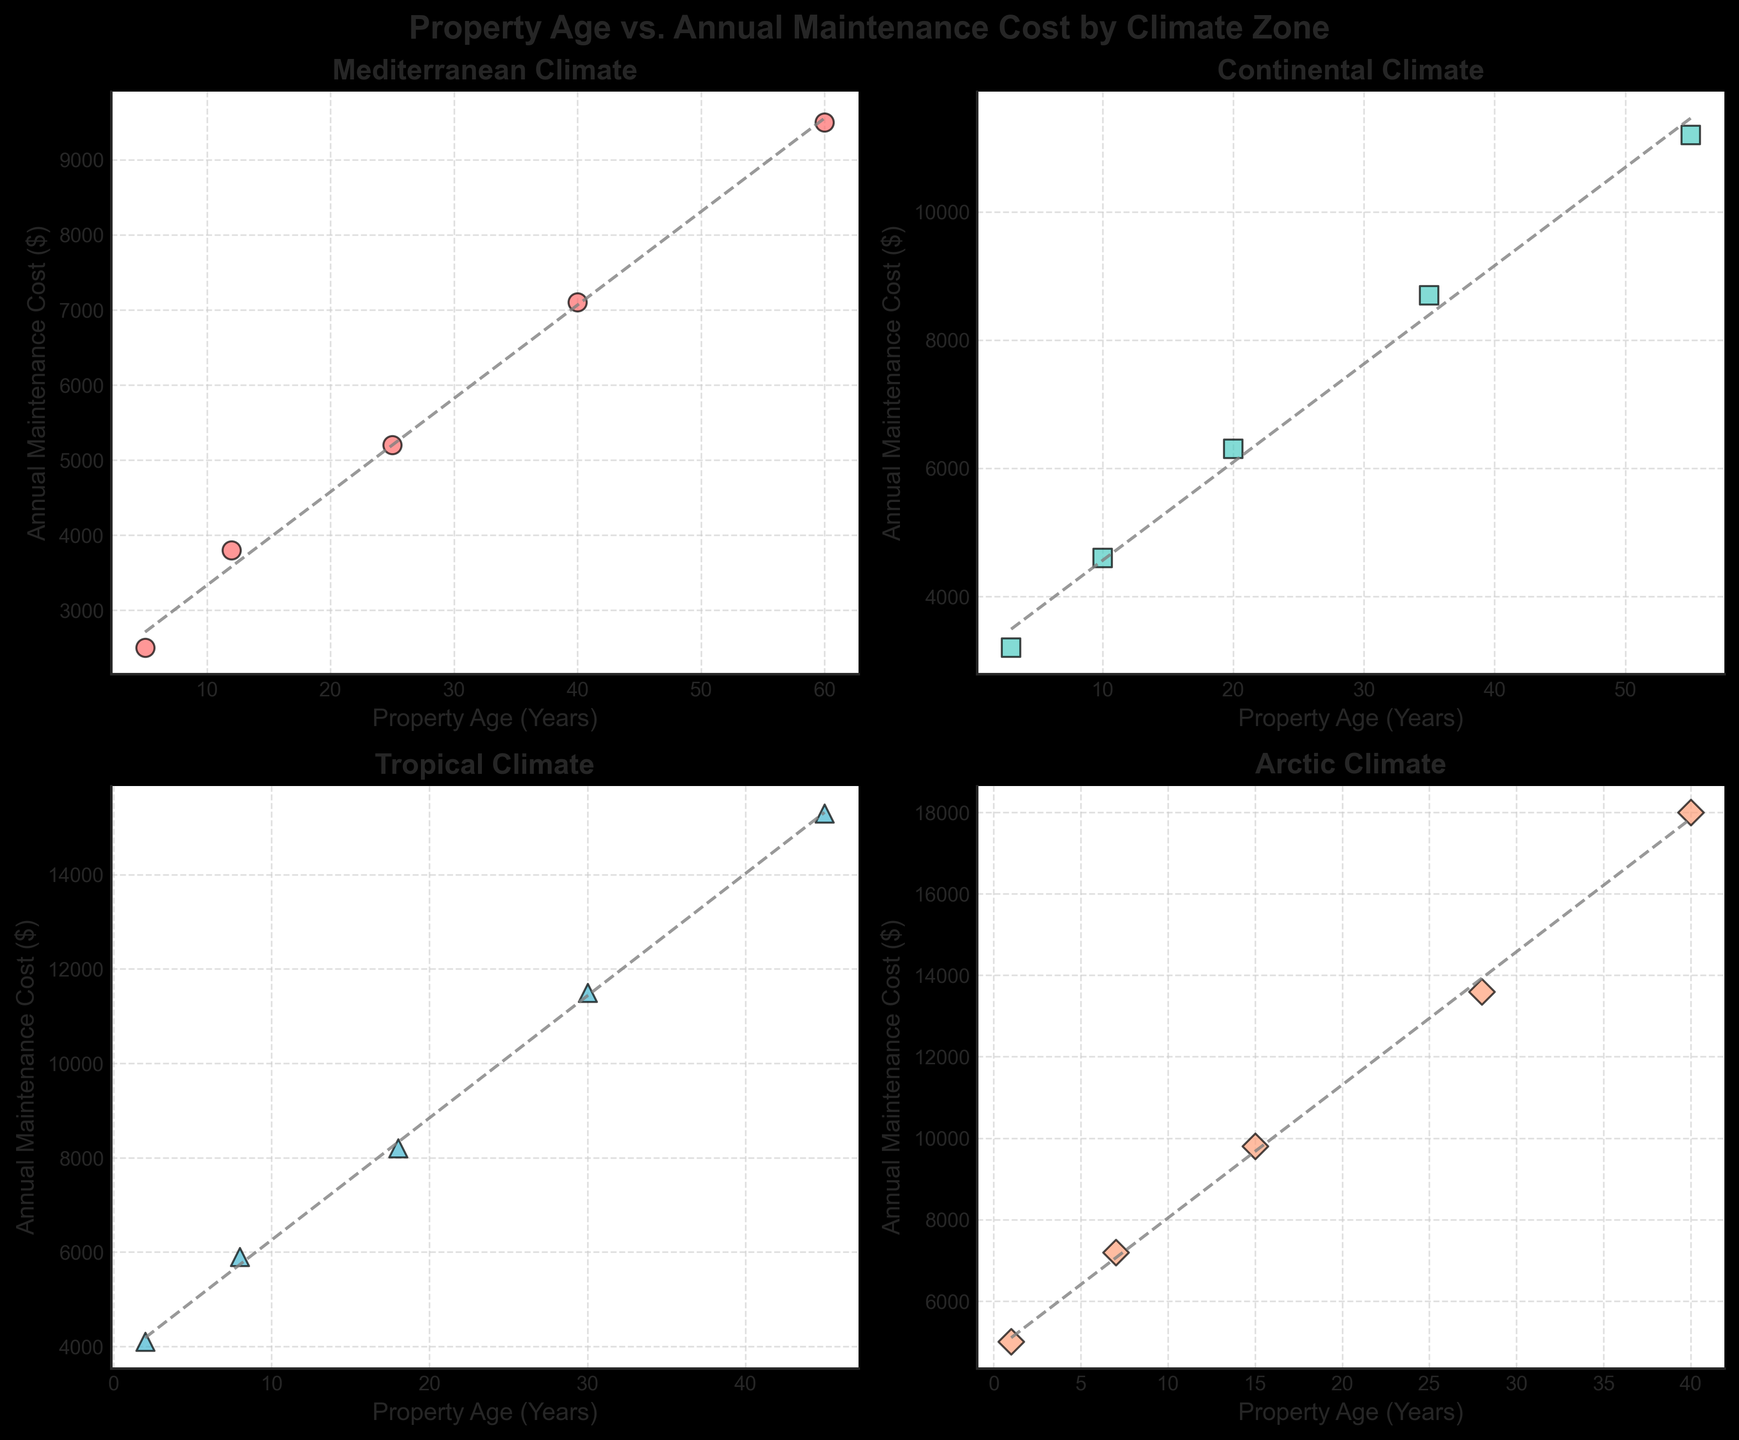What is the title of the figure? The title of the figure is located at the top, typically in bold font. It is a textual component that provides a summary of what the figure is about.
Answer: Property Age vs. Annual Maintenance Cost by Climate Zone How many climate zones are represented in the figure? By examining the titles of the subplots, we can count the number of different titles, each representing a climate zone
Answer: 4 In the Mediterranean climate zone, around what property age do maintenance costs start to exceed $5000 annually? Locate data points in the Mediterranean subplot where the y-axis (cost) values exceed $5000 and note the corresponding x-axis (age) value.
Answer: 25 years Which climate zone has the highest annual maintenance cost for the oldest properties? Compare the data points for the oldest properties in each subplot. The highest cost can be identified by observing the y-axis value of the data points for the oldest properties.
Answer: Arctic In which climate zone does the maintenance cost increase the steepest with property age? To determine the steepest increase, observe the slope of the trendlines added to each subplot. The subplot with the steepest trendline represents the climate zone with the steepest cost increase.
Answer: Arctic What is the annual maintenance cost for a property aged 35 years in the Continental climate zone? Locate the data point in the Continental subplot where the x-axis is 35 years and read the corresponding y-axis (cost) value.
Answer: $8700 Compare the annual maintenance cost of a 10-year-old property in the Mediterranean and Continental climate zones. Which one is higher? Identify the data points for 10-year-old properties in both subplots and compare their y-axis (cost) values.
Answer: Continental Which climate zone shows the most variability in maintenance costs for properties of different ages? Variability can be determined by observing the spread of data points within a subplot. The subplot with the widest spread indicates the most variability.
Answer: Arctic For properties aged 20 years, which climate zone has the lowest maintenance cost? Locate the data points for 20-year-old properties in each subplot and compare their y-axis (cost) values to find the lowest.
Answer: Mediterranean How does the trendline in the Tropical climate zone compare to that in the Arctic climate zone? Compare the slope and direction of the trendlines in the Tropical and Arctic subplots. The Arctic trendline is expected to have a steeper upward slope than the Tropical one.
Answer: Steeper in Arctic 